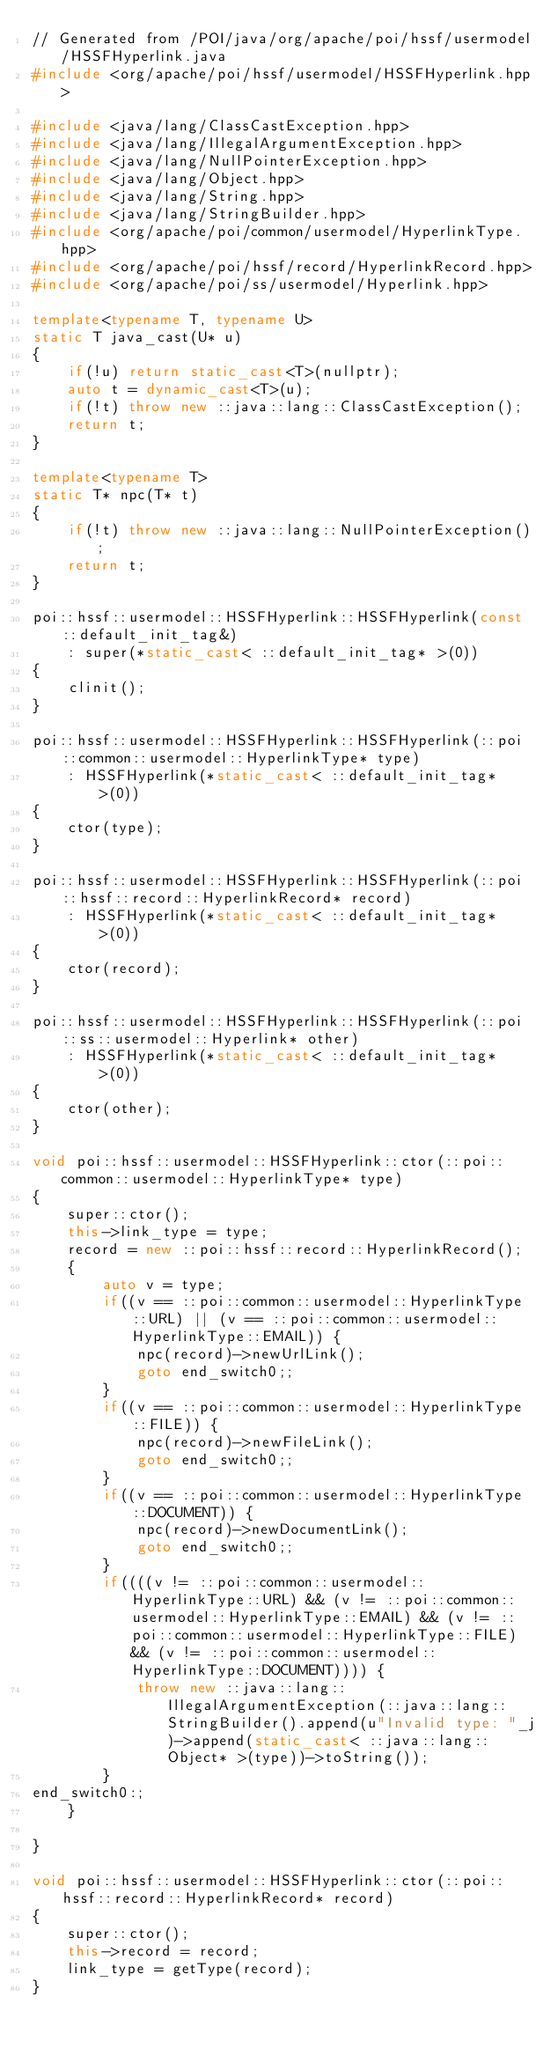Convert code to text. <code><loc_0><loc_0><loc_500><loc_500><_C++_>// Generated from /POI/java/org/apache/poi/hssf/usermodel/HSSFHyperlink.java
#include <org/apache/poi/hssf/usermodel/HSSFHyperlink.hpp>

#include <java/lang/ClassCastException.hpp>
#include <java/lang/IllegalArgumentException.hpp>
#include <java/lang/NullPointerException.hpp>
#include <java/lang/Object.hpp>
#include <java/lang/String.hpp>
#include <java/lang/StringBuilder.hpp>
#include <org/apache/poi/common/usermodel/HyperlinkType.hpp>
#include <org/apache/poi/hssf/record/HyperlinkRecord.hpp>
#include <org/apache/poi/ss/usermodel/Hyperlink.hpp>

template<typename T, typename U>
static T java_cast(U* u)
{
    if(!u) return static_cast<T>(nullptr);
    auto t = dynamic_cast<T>(u);
    if(!t) throw new ::java::lang::ClassCastException();
    return t;
}

template<typename T>
static T* npc(T* t)
{
    if(!t) throw new ::java::lang::NullPointerException();
    return t;
}

poi::hssf::usermodel::HSSFHyperlink::HSSFHyperlink(const ::default_init_tag&)
    : super(*static_cast< ::default_init_tag* >(0))
{
    clinit();
}

poi::hssf::usermodel::HSSFHyperlink::HSSFHyperlink(::poi::common::usermodel::HyperlinkType* type) 
    : HSSFHyperlink(*static_cast< ::default_init_tag* >(0))
{
    ctor(type);
}

poi::hssf::usermodel::HSSFHyperlink::HSSFHyperlink(::poi::hssf::record::HyperlinkRecord* record) 
    : HSSFHyperlink(*static_cast< ::default_init_tag* >(0))
{
    ctor(record);
}

poi::hssf::usermodel::HSSFHyperlink::HSSFHyperlink(::poi::ss::usermodel::Hyperlink* other) 
    : HSSFHyperlink(*static_cast< ::default_init_tag* >(0))
{
    ctor(other);
}

void poi::hssf::usermodel::HSSFHyperlink::ctor(::poi::common::usermodel::HyperlinkType* type)
{
    super::ctor();
    this->link_type = type;
    record = new ::poi::hssf::record::HyperlinkRecord();
    {
        auto v = type;
        if((v == ::poi::common::usermodel::HyperlinkType::URL) || (v == ::poi::common::usermodel::HyperlinkType::EMAIL)) {
            npc(record)->newUrlLink();
            goto end_switch0;;
        }
        if((v == ::poi::common::usermodel::HyperlinkType::FILE)) {
            npc(record)->newFileLink();
            goto end_switch0;;
        }
        if((v == ::poi::common::usermodel::HyperlinkType::DOCUMENT)) {
            npc(record)->newDocumentLink();
            goto end_switch0;;
        }
        if((((v != ::poi::common::usermodel::HyperlinkType::URL) && (v != ::poi::common::usermodel::HyperlinkType::EMAIL) && (v != ::poi::common::usermodel::HyperlinkType::FILE) && (v != ::poi::common::usermodel::HyperlinkType::DOCUMENT)))) {
            throw new ::java::lang::IllegalArgumentException(::java::lang::StringBuilder().append(u"Invalid type: "_j)->append(static_cast< ::java::lang::Object* >(type))->toString());
        }
end_switch0:;
    }

}

void poi::hssf::usermodel::HSSFHyperlink::ctor(::poi::hssf::record::HyperlinkRecord* record)
{
    super::ctor();
    this->record = record;
    link_type = getType(record);
}
</code> 